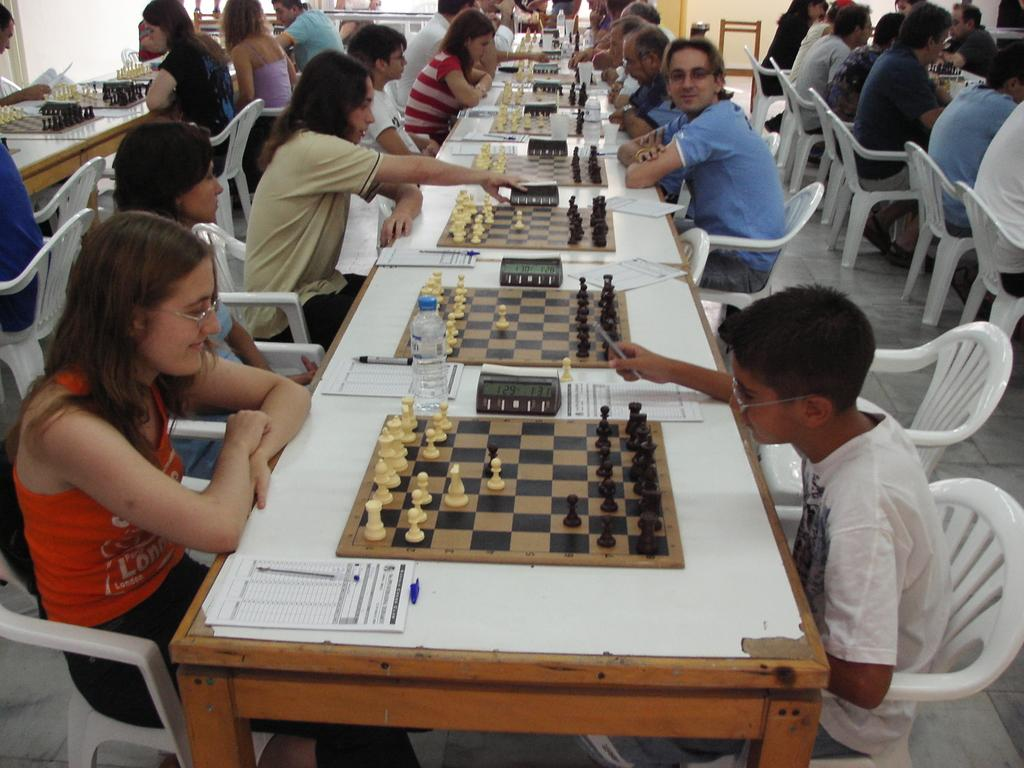How many people are in the image? There is a group of people in the image. What are the people doing in the image? The people are sitting on chairs and playing chess on the table. What is on the table in front of the people? There is a chessboard, papers, and pens on the table. What type of birds can be seen flying over the governor's head in the image? There is no governor or birds present in the image. What is the net used for in the image? There is no net present in the image. 